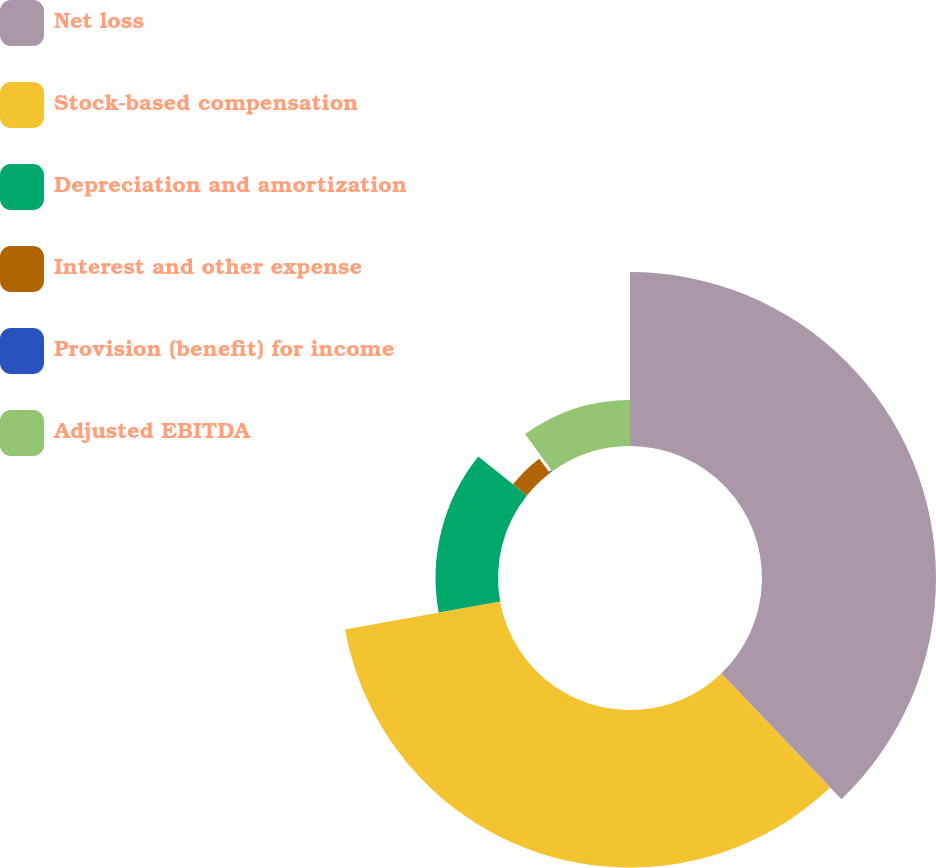Convert chart to OTSL. <chart><loc_0><loc_0><loc_500><loc_500><pie_chart><fcel>Net loss<fcel>Stock-based compensation<fcel>Depreciation and amortization<fcel>Interest and other expense<fcel>Provision (benefit) for income<fcel>Adjusted EBITDA<nl><fcel>37.86%<fcel>34.3%<fcel>13.59%<fcel>3.89%<fcel>0.33%<fcel>10.03%<nl></chart> 